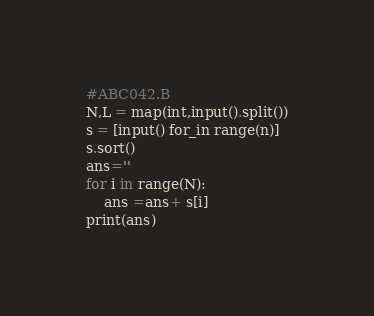<code> <loc_0><loc_0><loc_500><loc_500><_Python_>#ABC042.B
N,L = map(int,input().split())
s = [input() for_in range(n)]
s.sort()
ans=''
for i in range(N):
    ans =ans+ s[i]
print(ans)</code> 